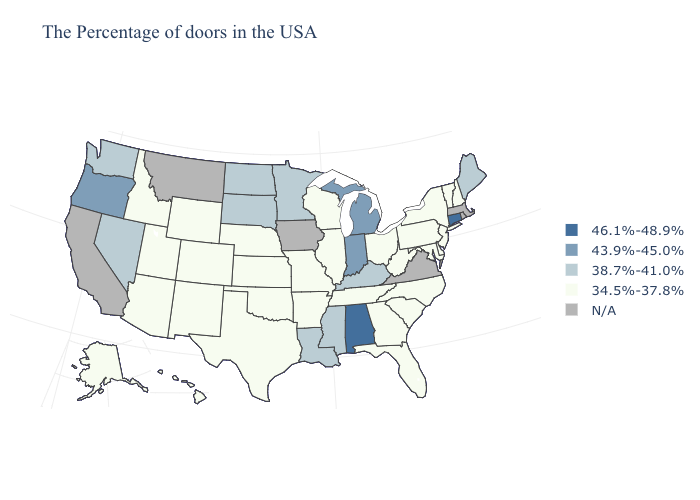Does Colorado have the lowest value in the West?
Quick response, please. Yes. Name the states that have a value in the range 43.9%-45.0%?
Short answer required. Michigan, Indiana, Oregon. What is the highest value in states that border Washington?
Give a very brief answer. 43.9%-45.0%. Does Alabama have the lowest value in the USA?
Be succinct. No. Name the states that have a value in the range 43.9%-45.0%?
Write a very short answer. Michigan, Indiana, Oregon. What is the highest value in states that border Georgia?
Keep it brief. 46.1%-48.9%. Does Kentucky have the highest value in the South?
Keep it brief. No. What is the value of New Hampshire?
Keep it brief. 34.5%-37.8%. Among the states that border South Dakota , does Nebraska have the lowest value?
Short answer required. Yes. Which states have the lowest value in the MidWest?
Give a very brief answer. Ohio, Wisconsin, Illinois, Missouri, Kansas, Nebraska. What is the highest value in states that border Iowa?
Concise answer only. 38.7%-41.0%. What is the highest value in states that border Utah?
Give a very brief answer. 38.7%-41.0%. What is the value of North Carolina?
Short answer required. 34.5%-37.8%. Among the states that border Michigan , does Ohio have the lowest value?
Answer briefly. Yes. Name the states that have a value in the range N/A?
Answer briefly. Massachusetts, Rhode Island, Virginia, Iowa, Montana, California. 